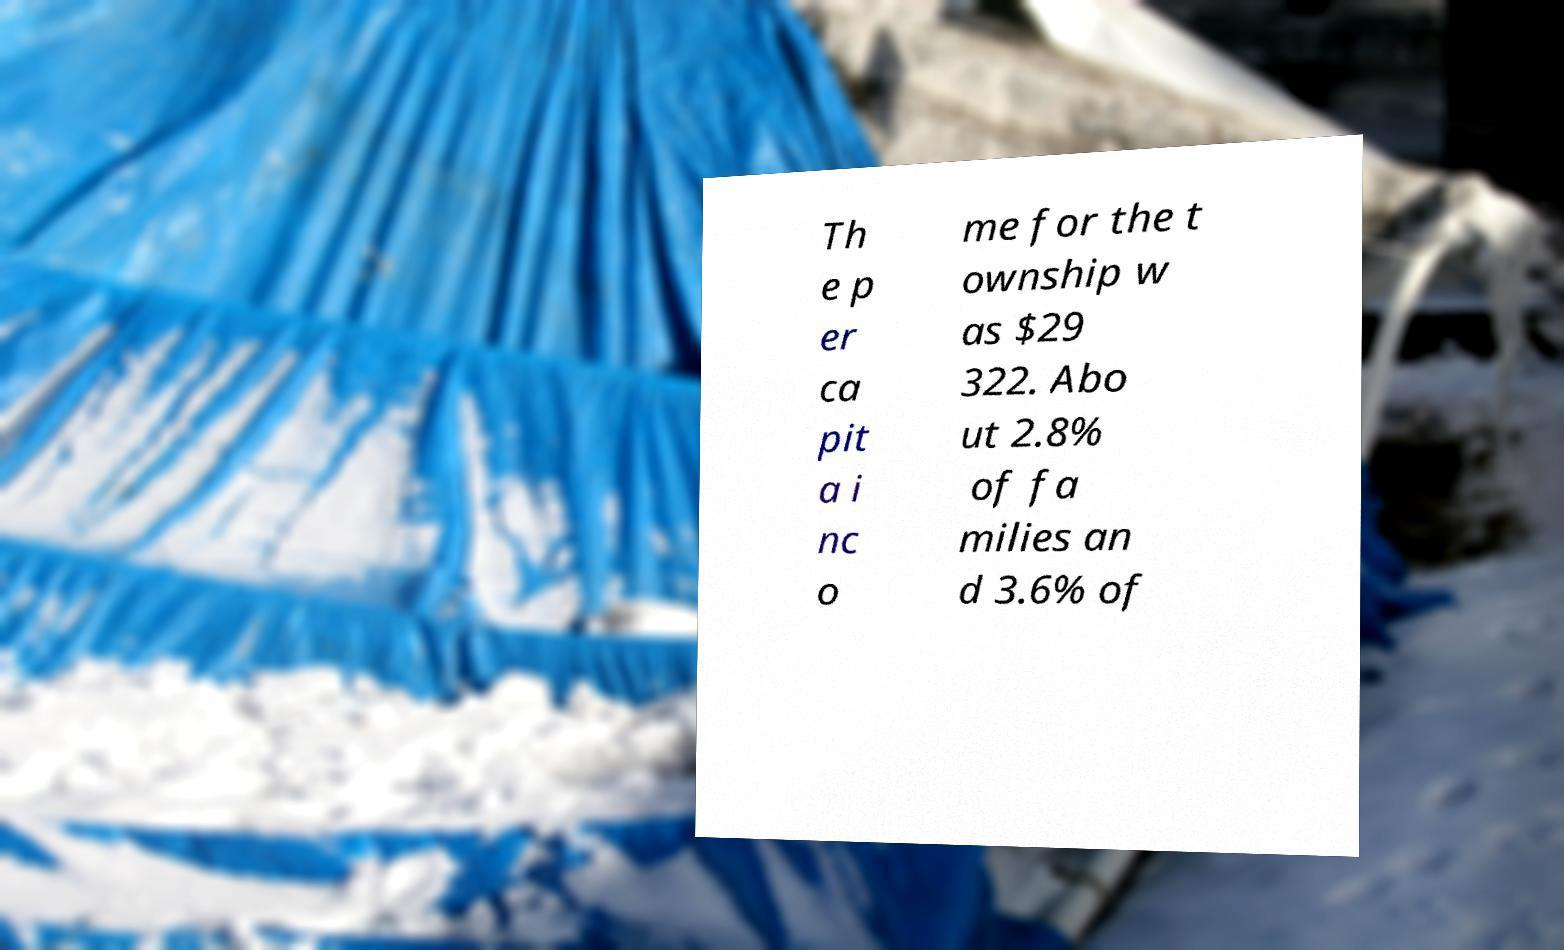I need the written content from this picture converted into text. Can you do that? Th e p er ca pit a i nc o me for the t ownship w as $29 322. Abo ut 2.8% of fa milies an d 3.6% of 